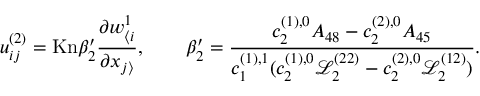<formula> <loc_0><loc_0><loc_500><loc_500>u _ { i j } ^ { ( 2 ) } = K n \beta _ { 2 } ^ { \prime } \frac { \partial w _ { \langle i } ^ { 1 } } { \partial x _ { j \rangle } } , \quad \beta _ { 2 } ^ { \prime } = \frac { c _ { 2 } ^ { ( 1 ) , 0 } A _ { 4 8 } - c _ { 2 } ^ { ( 2 ) , 0 } A _ { 4 5 } } { c _ { 1 } ^ { ( 1 ) , 1 } ( c _ { 2 } ^ { ( 1 ) , 0 } \ m a t h s c r { L } _ { 2 } ^ { ( 2 2 ) } - c _ { 2 } ^ { ( 2 ) , 0 } \ m a t h s c r { L } _ { 2 } ^ { ( 1 2 ) } ) } .</formula> 